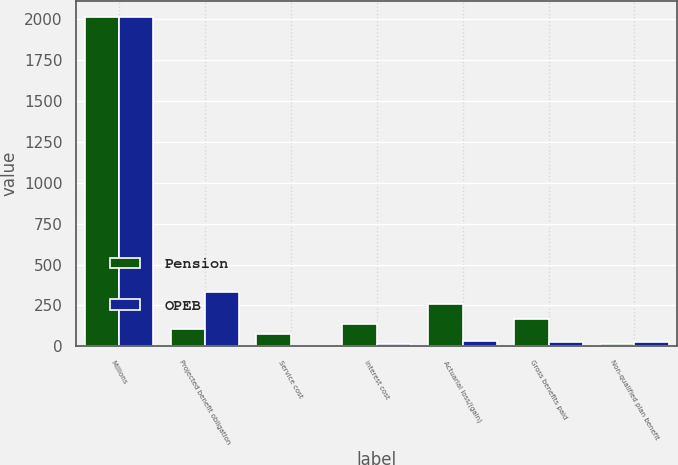Convert chart to OTSL. <chart><loc_0><loc_0><loc_500><loc_500><stacked_bar_chart><ecel><fcel>Millions<fcel>Projected benefit obligation<fcel>Service cost<fcel>Interest cost<fcel>Actuarial loss/(gain)<fcel>Gross benefits paid<fcel>Non-qualified plan benefit<nl><fcel>Pension<fcel>2013<fcel>103<fcel>72<fcel>134<fcel>257<fcel>168<fcel>16<nl><fcel>OPEB<fcel>2013<fcel>330<fcel>3<fcel>12<fcel>34<fcel>23<fcel>23<nl></chart> 